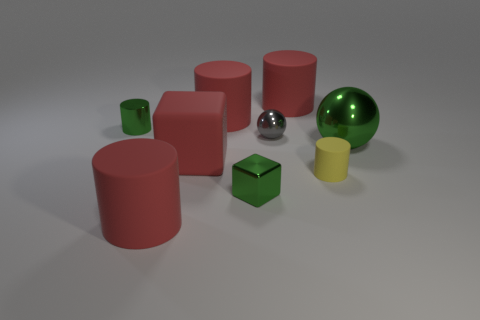Subtract all red cylinders. How many were subtracted if there are1red cylinders left? 2 Add 1 tiny green metallic things. How many objects exist? 10 Subtract all yellow cylinders. How many cylinders are left? 4 Subtract all rubber cylinders. How many cylinders are left? 1 Subtract all spheres. How many objects are left? 7 Subtract 1 blocks. How many blocks are left? 1 Subtract all gray blocks. How many brown cylinders are left? 0 Subtract all blocks. Subtract all green cubes. How many objects are left? 6 Add 5 large red objects. How many large red objects are left? 9 Add 1 big gray metal cylinders. How many big gray metal cylinders exist? 1 